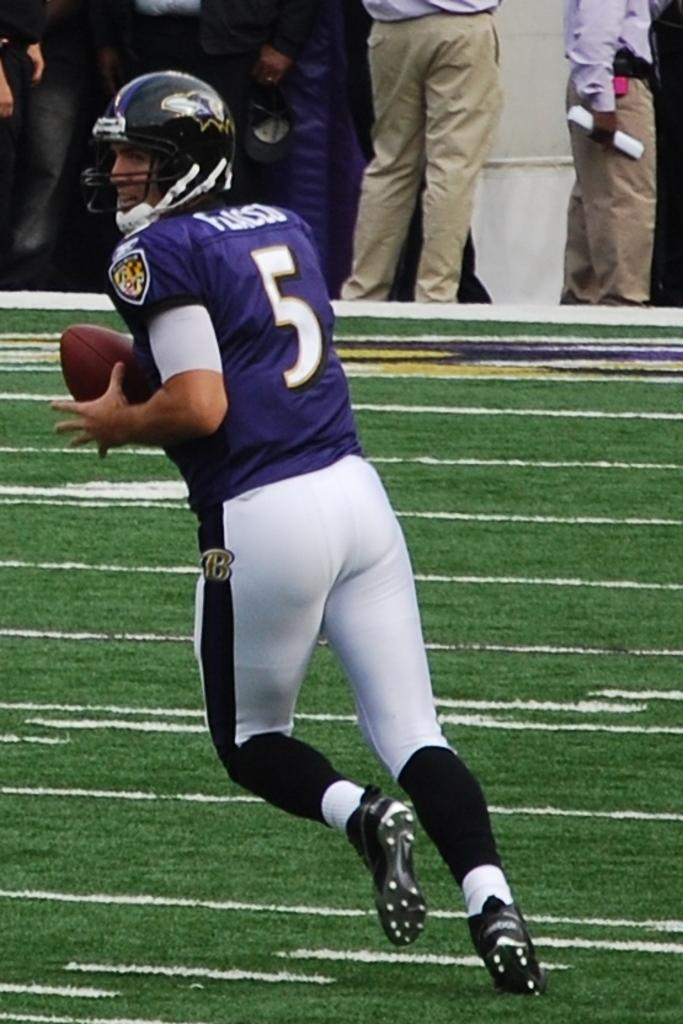Who is the main subject in the image? There is a man in the image. What is the man doing in the image? The man is on the floor and holding a ball with his hand. Can you describe the background of the image? There are people visible in the background of the image. What type of soap is the man using to talk to the ball in the image? There is no soap present in the image, and the man is not talking to the ball. 